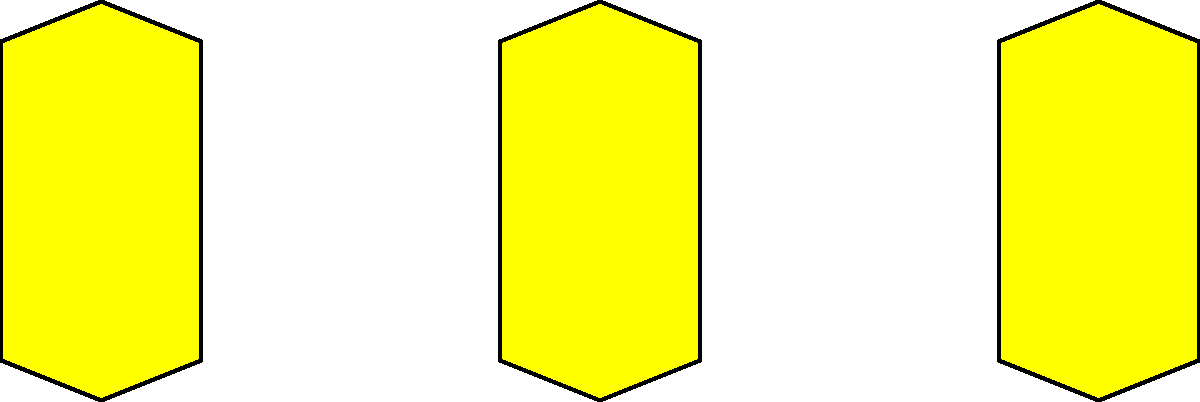How many award nominations has Caylee Cowan received for her acting performances as of 2023? To answer this question, let's break down Caylee Cowan's career and nominations:

1. Caylee Cowan is a relatively new actress in Hollywood, having started her career in the late 2010s.

2. As of 2023, Caylee Cowan has not received any major award nominations from prestigious organizations like the Academy Awards, Golden Globes, or Emmy Awards.

3. However, Caylee Cowan has been recognized for her work in independent films. In 2021, she received a nomination for Best Actress at the Venice Short Film Awards for her role in the short film "Wired."

4. This nomination at the Venice Short Film Awards is currently the only known award nomination for Caylee Cowan's acting performances.

5. It's important to note that as a rising actress, Cowan's career is still developing, and future nominations may come as she takes on more roles and gains more recognition in the industry.

Based on this information, we can conclude that Caylee Cowan has received one award nomination for her acting performances as of 2023.
Answer: 1 